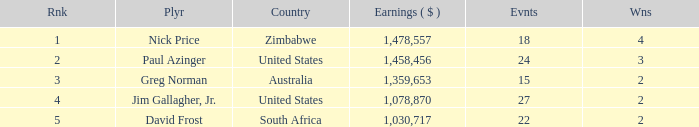Could you parse the entire table? {'header': ['Rnk', 'Plyr', 'Country', 'Earnings ( $ )', 'Evnts', 'Wns'], 'rows': [['1', 'Nick Price', 'Zimbabwe', '1,478,557', '18', '4'], ['2', 'Paul Azinger', 'United States', '1,458,456', '24', '3'], ['3', 'Greg Norman', 'Australia', '1,359,653', '15', '2'], ['4', 'Jim Gallagher, Jr.', 'United States', '1,078,870', '27', '2'], ['5', 'David Frost', 'South Africa', '1,030,717', '22', '2']]} How many events have earnings less than 1,030,717? 0.0. 